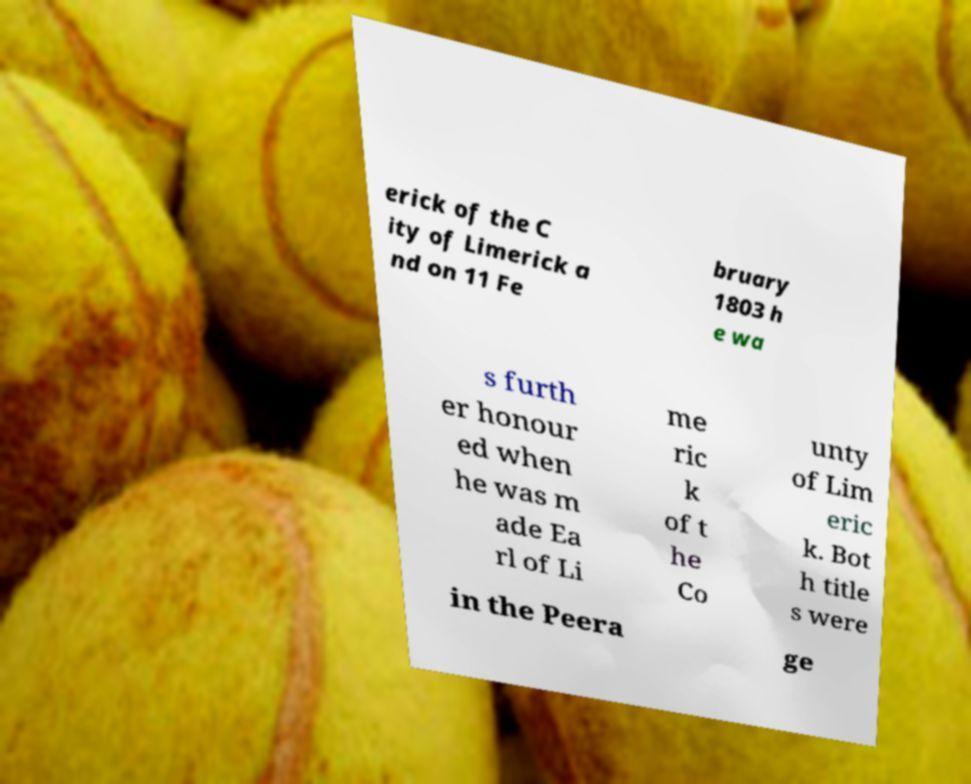Can you accurately transcribe the text from the provided image for me? erick of the C ity of Limerick a nd on 11 Fe bruary 1803 h e wa s furth er honour ed when he was m ade Ea rl of Li me ric k of t he Co unty of Lim eric k. Bot h title s were in the Peera ge 